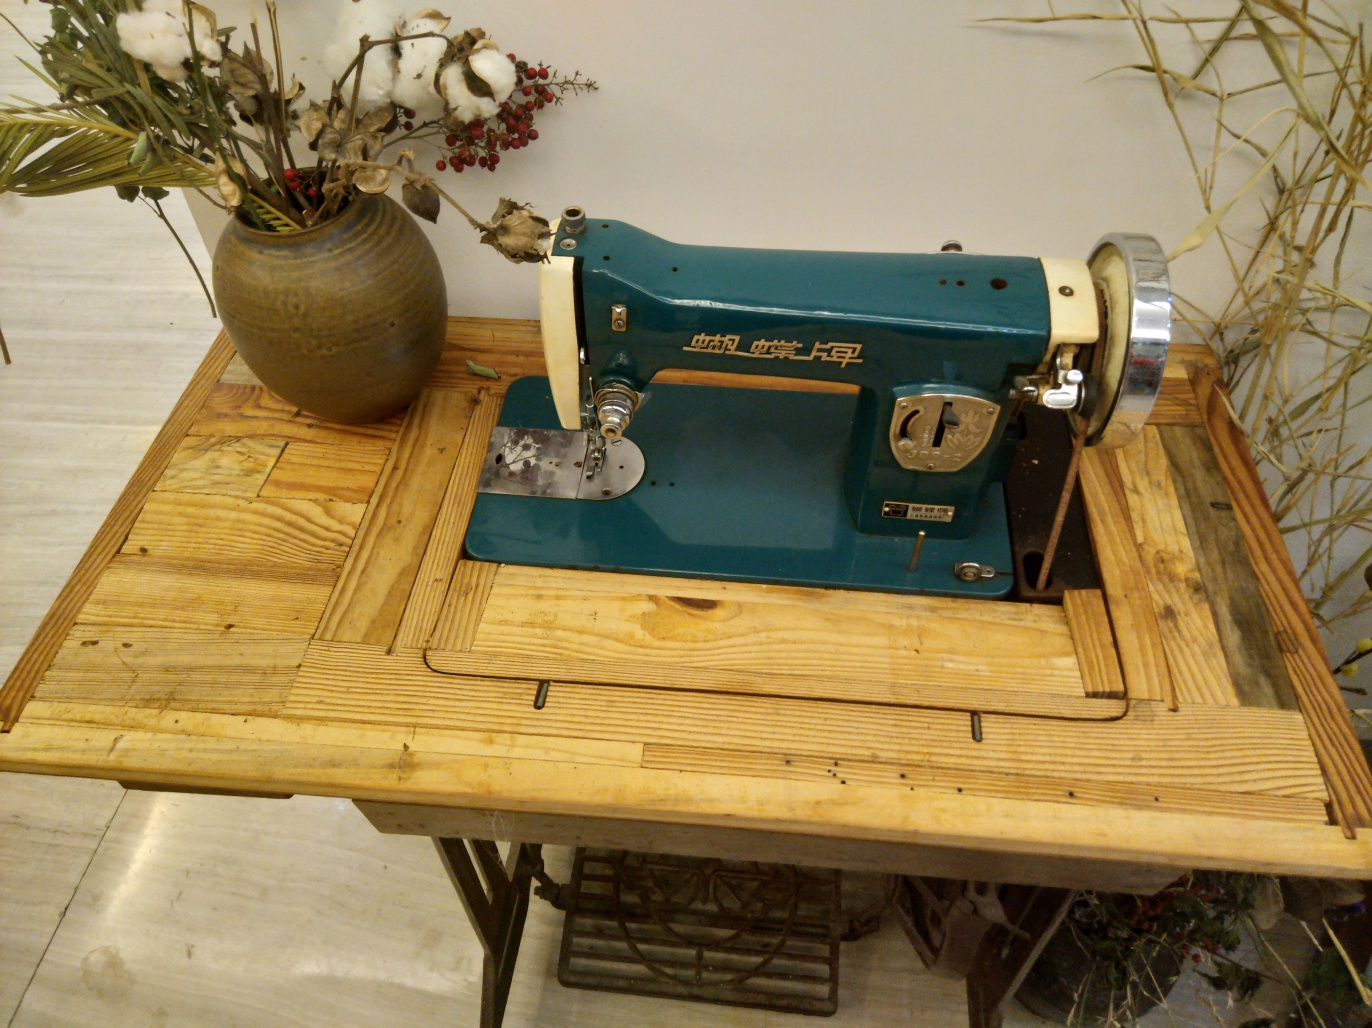What contrasts can you observe in this image, and how do they interact with each other? There's a striking contrast between the industrial design of the teal sewing machine and the organic texture of the dry vegetation. Another contrast is between the sleek metal components of the sewing machine and the warm, worn wooden textures of the table and the floor. These contrasts interact to create a harmonious balance, integrating man-made machinery with elements of nature. 